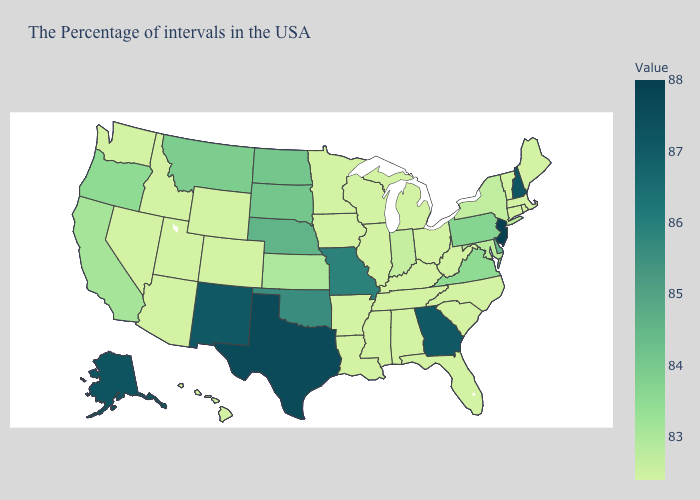Does Michigan have the highest value in the MidWest?
Quick response, please. No. Is the legend a continuous bar?
Answer briefly. Yes. Which states hav the highest value in the Northeast?
Write a very short answer. New Jersey. Which states have the lowest value in the USA?
Keep it brief. Maine, Massachusetts, Rhode Island, Vermont, Connecticut, North Carolina, South Carolina, West Virginia, Ohio, Florida, Michigan, Kentucky, Alabama, Tennessee, Wisconsin, Illinois, Mississippi, Louisiana, Arkansas, Minnesota, Iowa, Wyoming, Colorado, Utah, Arizona, Idaho, Nevada, Washington, Hawaii. Does Missouri have the lowest value in the MidWest?
Short answer required. No. Which states hav the highest value in the South?
Answer briefly. Texas. 